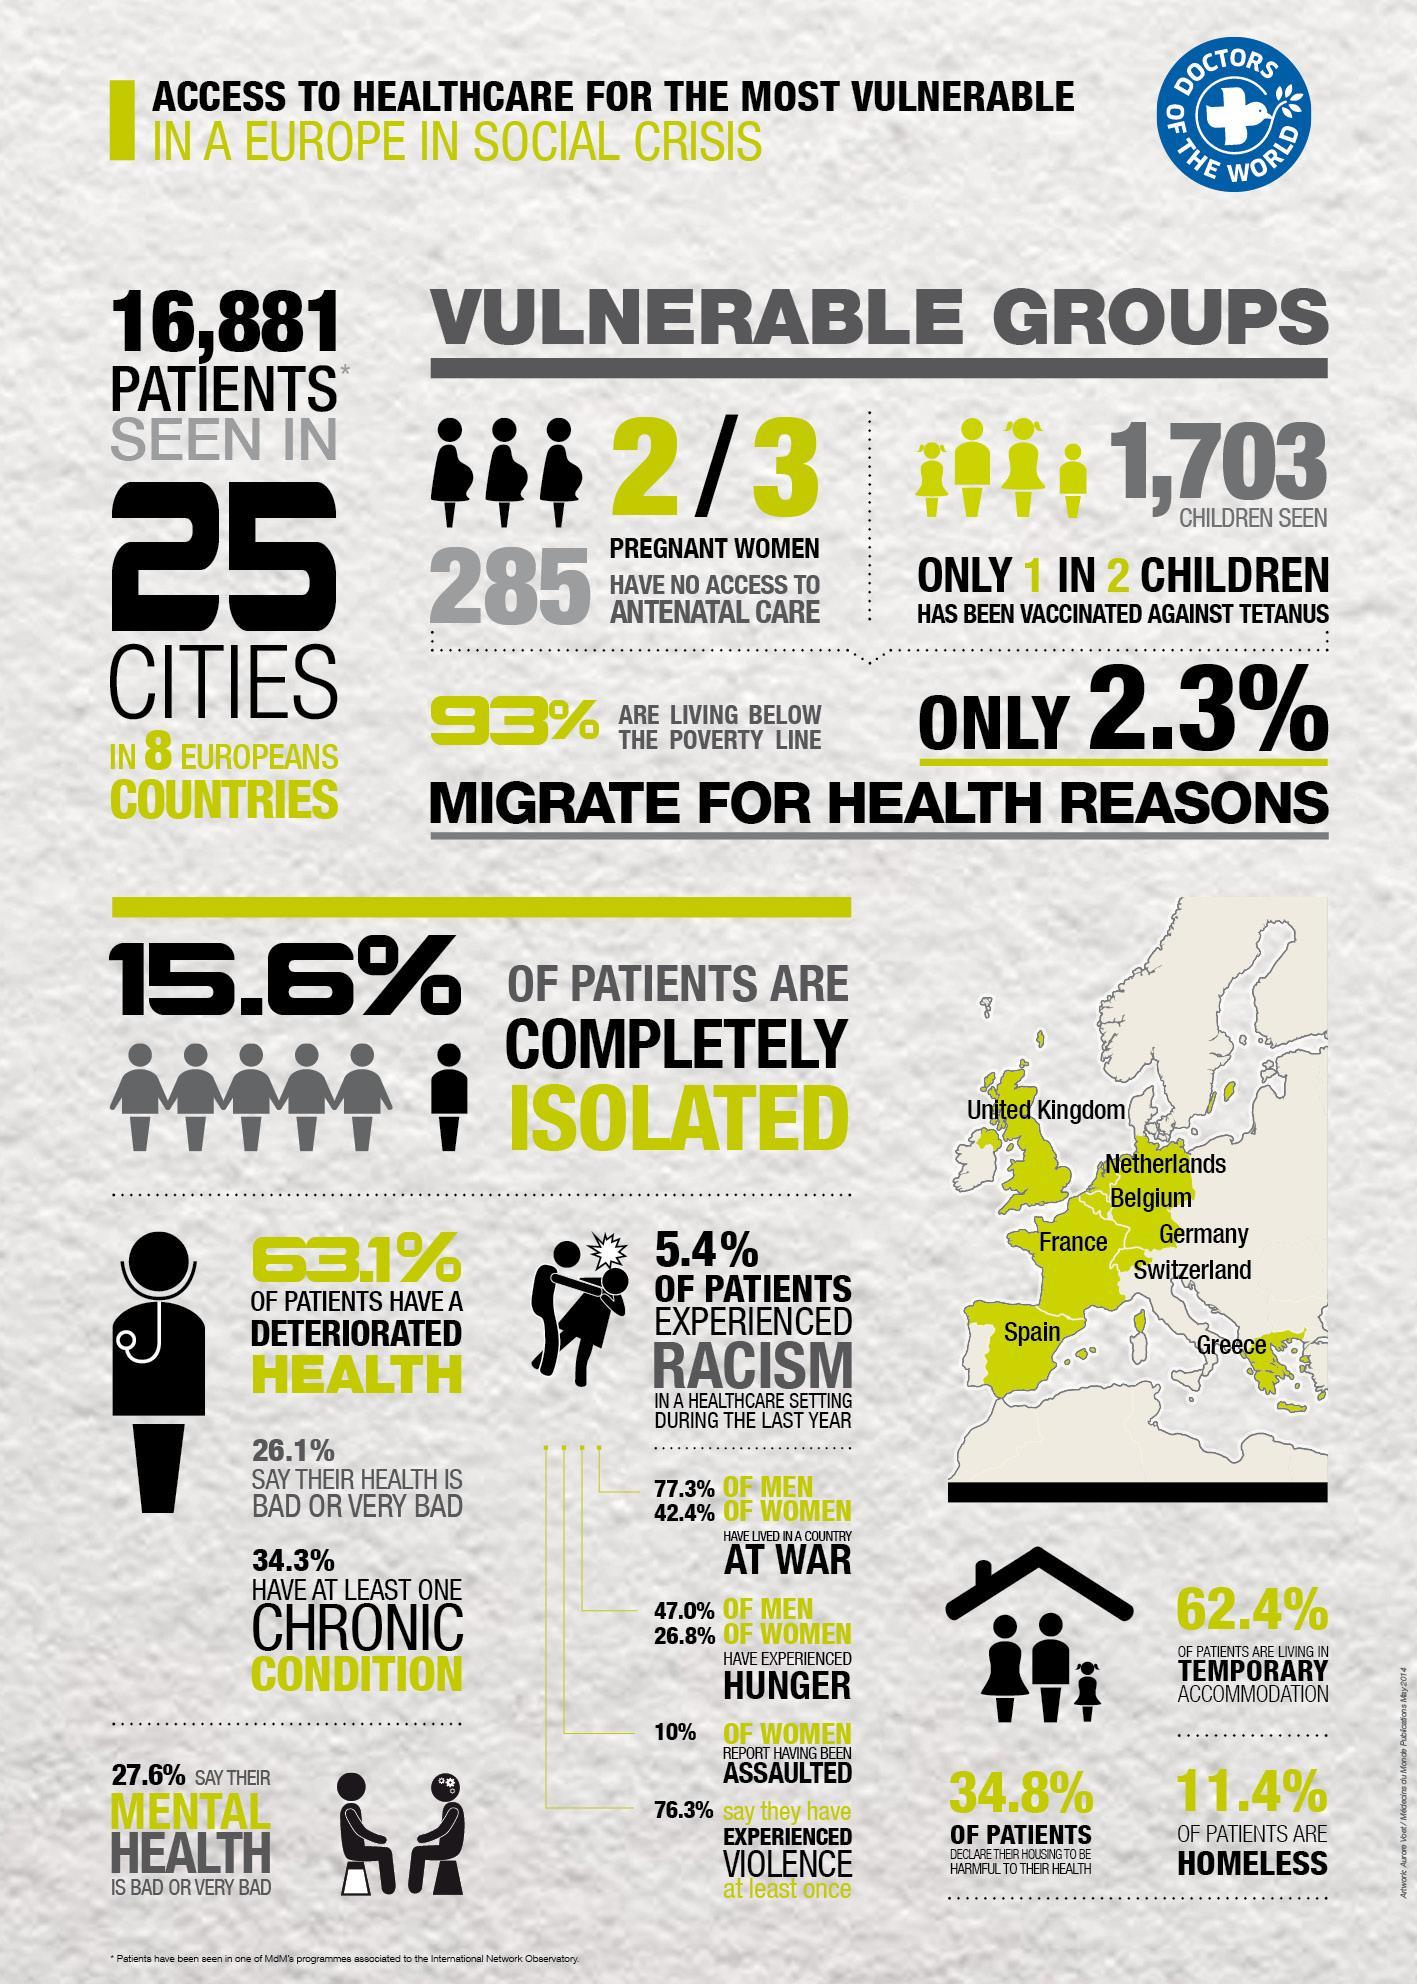What percent of patients didn't experience racism in a healthcare setting during the last year?
Answer the question with a short phrase. 94.6% How many children in Europe has been vaccinated against tetanus? 1,703 How many pregnant women have no access to antenatal care in Europe? 285 What percentage of men have lived in a country at war? 77.3% What percent of Europeans migrate due to health reasons? 2.3% What percentage of men in Europe have experienced hunger? 47.0% What percentage of people in Europe are living above the poverty line? 7% What percent of patients have at least one chronic condition? 34.3% 